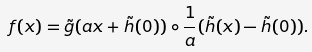<formula> <loc_0><loc_0><loc_500><loc_500>f ( x ) = \tilde { g } ( a x + \tilde { h } ( 0 ) ) \circ \frac { 1 } { a } ( \tilde { h } ( x ) - \tilde { h } ( 0 ) ) .</formula> 